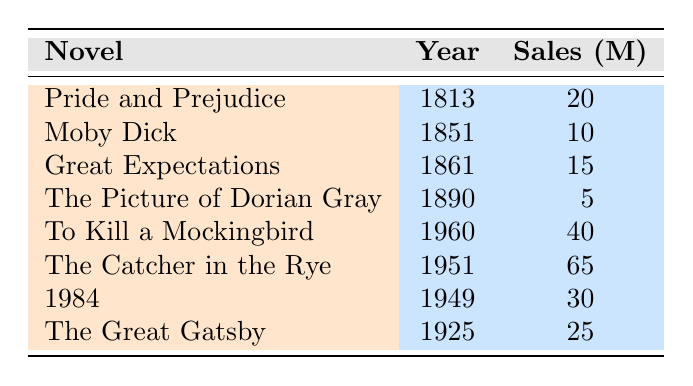What is the publication year of "The Great Gatsby"? By looking at the table, we can find the title "The Great Gatsby" in the first column. The publication year listed next to it is 1925.
Answer: 1925 Which novel has the highest sales figures? Scanning through the sales figures column, "The Catcher in the Rye" has the highest sales at 65 million.
Answer: The Catcher in the Rye What is the average sales figure of the novels published before 1900? The novels published before 1900 are "Pride and Prejudice" (20), "Moby Dick" (10), "Great Expectations" (15), and "The Picture of Dorian Gray" (5). To find the average, we sum these values: 20 + 10 + 15 + 5 = 50. There are 4 novels, so the average is 50/4 = 12.5.
Answer: 12.5 Is it true that "1984" was published after "To Kill a Mockingbird"? Checking the publication years, "1984" is published in 1949 and "To Kill a Mockingbird" is published in 1960. Therefore, since 1949 is before 1960, the statement is false.
Answer: No What is the difference between the sales figures of the best-selling and the least-selling novel? The best-selling novel is "The Catcher in the Rye" with 65 million sales, and the least-selling novel is "The Picture of Dorian Gray" with 5 million. The difference is calculated as 65 - 5 = 60 million.
Answer: 60 million How many novels in the list have sales figures of 20 million or more? Looking at the sales figures, the novels with 20 million or more are "Pride and Prejudice" (20), "The Great Gatsby" (25), "1984" (30), "To Kill a Mockingbird" (40), and "The Catcher in the Rye" (65). There are 5 such novels.
Answer: 5 What is the median year of publication for the novels listed? The publication years are 1813, 1851, 1861, 1890, 1925, 1949, 1951, and 1960. Arranging these in order gives us: 1813, 1851, 1861, 1890, 1925, 1949, 1951, 1960. With 8 numbers, the median is the average of the 4th and 5th values: (1890 + 1925)/2 = 1907.5.
Answer: 1907.5 